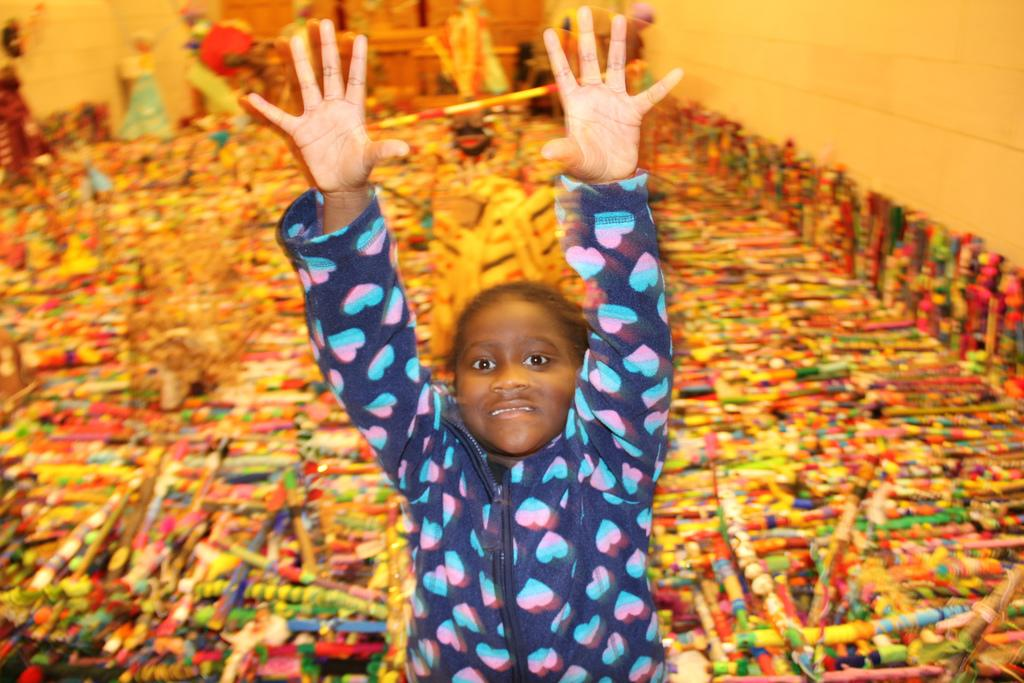Who is the main subject in the image? There is a person in the center of the image. What is the person wearing? The person is wearing a blue jacket. How is the person positioned in the image? The person appears to be standing. What can be seen in the background of the image? There are colorful objects and a wall visible in the background of the image. What type of zipper can be seen on the person's jacket in the image? There is no zipper visible on the person's jacket in the image. What treatment is the person receiving for their condition in the image? There is no indication of any medical condition or treatment in the image. 